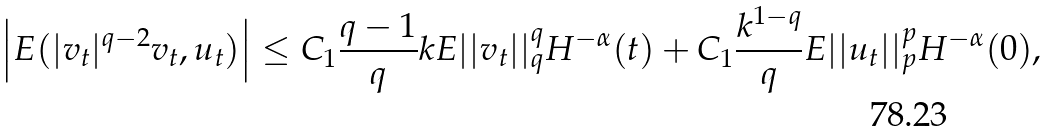<formula> <loc_0><loc_0><loc_500><loc_500>\left | E ( | v _ { t } | ^ { q - 2 } v _ { t } , u _ { t } ) \right | \leq C _ { 1 } \frac { q - 1 } { q } k E | | v _ { t } | | ^ { q } _ { q } H ^ { - \alpha } ( t ) + C _ { 1 } \frac { k ^ { 1 - q } } { q } E | | u _ { t } | | ^ { p } _ { p } H ^ { - \alpha } ( 0 ) ,</formula> 